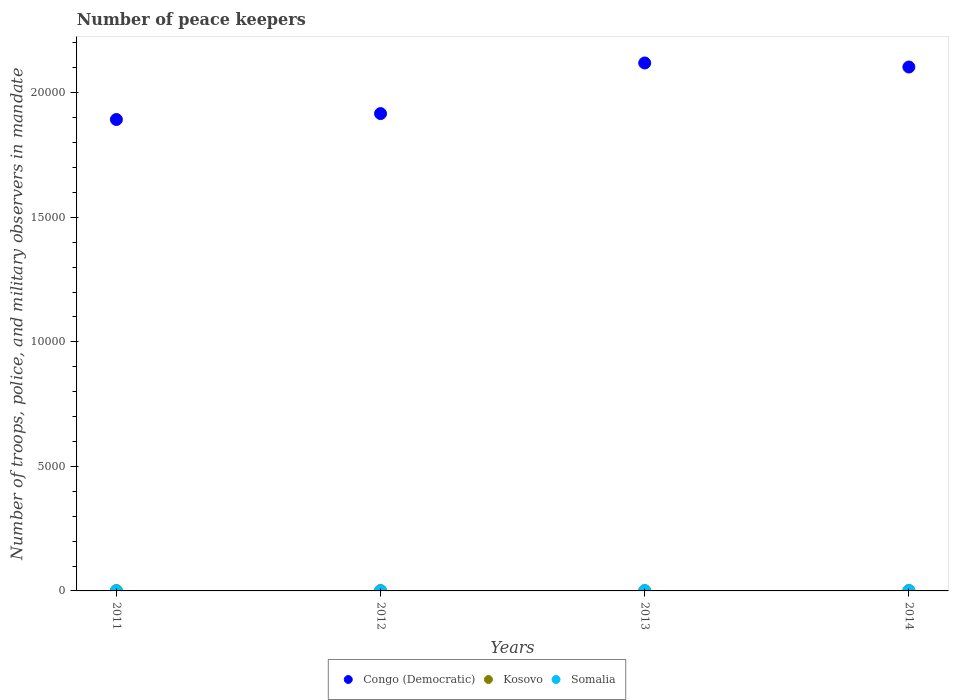How many different coloured dotlines are there?
Make the answer very short. 3. Across all years, what is the maximum number of peace keepers in in Congo (Democratic)?
Keep it short and to the point. 2.12e+04. Across all years, what is the minimum number of peace keepers in in Congo (Democratic)?
Your response must be concise. 1.89e+04. In which year was the number of peace keepers in in Kosovo minimum?
Your answer should be compact. 2013. What is the difference between the number of peace keepers in in Congo (Democratic) in 2011 and that in 2013?
Provide a succinct answer. -2270. What is the difference between the number of peace keepers in in Congo (Democratic) in 2011 and the number of peace keepers in in Kosovo in 2012?
Ensure brevity in your answer.  1.89e+04. What is the average number of peace keepers in in Congo (Democratic) per year?
Provide a short and direct response. 2.01e+04. In the year 2014, what is the difference between the number of peace keepers in in Congo (Democratic) and number of peace keepers in in Kosovo?
Provide a succinct answer. 2.10e+04. What is the ratio of the number of peace keepers in in Congo (Democratic) in 2013 to that in 2014?
Offer a very short reply. 1.01. Is the number of peace keepers in in Somalia in 2013 less than that in 2014?
Provide a succinct answer. Yes. Is the difference between the number of peace keepers in in Congo (Democratic) in 2011 and 2013 greater than the difference between the number of peace keepers in in Kosovo in 2011 and 2013?
Your response must be concise. No. Is the sum of the number of peace keepers in in Somalia in 2012 and 2014 greater than the maximum number of peace keepers in in Congo (Democratic) across all years?
Offer a terse response. No. Is the number of peace keepers in in Somalia strictly less than the number of peace keepers in in Kosovo over the years?
Provide a succinct answer. Yes. How many dotlines are there?
Provide a short and direct response. 3. How many years are there in the graph?
Make the answer very short. 4. What is the difference between two consecutive major ticks on the Y-axis?
Give a very brief answer. 5000. Are the values on the major ticks of Y-axis written in scientific E-notation?
Your response must be concise. No. How are the legend labels stacked?
Provide a short and direct response. Horizontal. What is the title of the graph?
Your response must be concise. Number of peace keepers. Does "Liechtenstein" appear as one of the legend labels in the graph?
Provide a short and direct response. No. What is the label or title of the X-axis?
Make the answer very short. Years. What is the label or title of the Y-axis?
Provide a short and direct response. Number of troops, police, and military observers in mandate. What is the Number of troops, police, and military observers in mandate in Congo (Democratic) in 2011?
Your response must be concise. 1.89e+04. What is the Number of troops, police, and military observers in mandate in Kosovo in 2011?
Offer a very short reply. 16. What is the Number of troops, police, and military observers in mandate of Congo (Democratic) in 2012?
Provide a short and direct response. 1.92e+04. What is the Number of troops, police, and military observers in mandate of Congo (Democratic) in 2013?
Provide a short and direct response. 2.12e+04. What is the Number of troops, police, and military observers in mandate in Kosovo in 2013?
Your response must be concise. 14. What is the Number of troops, police, and military observers in mandate of Congo (Democratic) in 2014?
Your answer should be compact. 2.10e+04. What is the Number of troops, police, and military observers in mandate in Kosovo in 2014?
Offer a terse response. 16. What is the Number of troops, police, and military observers in mandate in Somalia in 2014?
Offer a terse response. 12. Across all years, what is the maximum Number of troops, police, and military observers in mandate in Congo (Democratic)?
Your answer should be compact. 2.12e+04. Across all years, what is the maximum Number of troops, police, and military observers in mandate in Somalia?
Keep it short and to the point. 12. Across all years, what is the minimum Number of troops, police, and military observers in mandate of Congo (Democratic)?
Your answer should be compact. 1.89e+04. Across all years, what is the minimum Number of troops, police, and military observers in mandate of Kosovo?
Make the answer very short. 14. Across all years, what is the minimum Number of troops, police, and military observers in mandate of Somalia?
Your answer should be compact. 3. What is the total Number of troops, police, and military observers in mandate in Congo (Democratic) in the graph?
Keep it short and to the point. 8.03e+04. What is the total Number of troops, police, and military observers in mandate of Somalia in the graph?
Give a very brief answer. 30. What is the difference between the Number of troops, police, and military observers in mandate in Congo (Democratic) in 2011 and that in 2012?
Make the answer very short. -238. What is the difference between the Number of troops, police, and military observers in mandate in Kosovo in 2011 and that in 2012?
Give a very brief answer. 0. What is the difference between the Number of troops, police, and military observers in mandate in Somalia in 2011 and that in 2012?
Provide a short and direct response. 3. What is the difference between the Number of troops, police, and military observers in mandate in Congo (Democratic) in 2011 and that in 2013?
Provide a succinct answer. -2270. What is the difference between the Number of troops, police, and military observers in mandate in Congo (Democratic) in 2011 and that in 2014?
Your answer should be very brief. -2108. What is the difference between the Number of troops, police, and military observers in mandate of Congo (Democratic) in 2012 and that in 2013?
Provide a succinct answer. -2032. What is the difference between the Number of troops, police, and military observers in mandate of Kosovo in 2012 and that in 2013?
Your answer should be very brief. 2. What is the difference between the Number of troops, police, and military observers in mandate in Somalia in 2012 and that in 2013?
Offer a very short reply. -6. What is the difference between the Number of troops, police, and military observers in mandate in Congo (Democratic) in 2012 and that in 2014?
Offer a terse response. -1870. What is the difference between the Number of troops, police, and military observers in mandate of Congo (Democratic) in 2013 and that in 2014?
Provide a succinct answer. 162. What is the difference between the Number of troops, police, and military observers in mandate in Kosovo in 2013 and that in 2014?
Provide a short and direct response. -2. What is the difference between the Number of troops, police, and military observers in mandate of Somalia in 2013 and that in 2014?
Your answer should be compact. -3. What is the difference between the Number of troops, police, and military observers in mandate of Congo (Democratic) in 2011 and the Number of troops, police, and military observers in mandate of Kosovo in 2012?
Offer a very short reply. 1.89e+04. What is the difference between the Number of troops, police, and military observers in mandate of Congo (Democratic) in 2011 and the Number of troops, police, and military observers in mandate of Somalia in 2012?
Keep it short and to the point. 1.89e+04. What is the difference between the Number of troops, police, and military observers in mandate of Kosovo in 2011 and the Number of troops, police, and military observers in mandate of Somalia in 2012?
Keep it short and to the point. 13. What is the difference between the Number of troops, police, and military observers in mandate of Congo (Democratic) in 2011 and the Number of troops, police, and military observers in mandate of Kosovo in 2013?
Offer a very short reply. 1.89e+04. What is the difference between the Number of troops, police, and military observers in mandate of Congo (Democratic) in 2011 and the Number of troops, police, and military observers in mandate of Somalia in 2013?
Ensure brevity in your answer.  1.89e+04. What is the difference between the Number of troops, police, and military observers in mandate of Congo (Democratic) in 2011 and the Number of troops, police, and military observers in mandate of Kosovo in 2014?
Offer a very short reply. 1.89e+04. What is the difference between the Number of troops, police, and military observers in mandate in Congo (Democratic) in 2011 and the Number of troops, police, and military observers in mandate in Somalia in 2014?
Your answer should be compact. 1.89e+04. What is the difference between the Number of troops, police, and military observers in mandate of Kosovo in 2011 and the Number of troops, police, and military observers in mandate of Somalia in 2014?
Your answer should be very brief. 4. What is the difference between the Number of troops, police, and military observers in mandate in Congo (Democratic) in 2012 and the Number of troops, police, and military observers in mandate in Kosovo in 2013?
Offer a very short reply. 1.92e+04. What is the difference between the Number of troops, police, and military observers in mandate of Congo (Democratic) in 2012 and the Number of troops, police, and military observers in mandate of Somalia in 2013?
Your response must be concise. 1.92e+04. What is the difference between the Number of troops, police, and military observers in mandate of Kosovo in 2012 and the Number of troops, police, and military observers in mandate of Somalia in 2013?
Your answer should be very brief. 7. What is the difference between the Number of troops, police, and military observers in mandate of Congo (Democratic) in 2012 and the Number of troops, police, and military observers in mandate of Kosovo in 2014?
Your response must be concise. 1.92e+04. What is the difference between the Number of troops, police, and military observers in mandate in Congo (Democratic) in 2012 and the Number of troops, police, and military observers in mandate in Somalia in 2014?
Provide a succinct answer. 1.92e+04. What is the difference between the Number of troops, police, and military observers in mandate in Kosovo in 2012 and the Number of troops, police, and military observers in mandate in Somalia in 2014?
Offer a terse response. 4. What is the difference between the Number of troops, police, and military observers in mandate in Congo (Democratic) in 2013 and the Number of troops, police, and military observers in mandate in Kosovo in 2014?
Ensure brevity in your answer.  2.12e+04. What is the difference between the Number of troops, police, and military observers in mandate of Congo (Democratic) in 2013 and the Number of troops, police, and military observers in mandate of Somalia in 2014?
Ensure brevity in your answer.  2.12e+04. What is the difference between the Number of troops, police, and military observers in mandate of Kosovo in 2013 and the Number of troops, police, and military observers in mandate of Somalia in 2014?
Make the answer very short. 2. What is the average Number of troops, police, and military observers in mandate of Congo (Democratic) per year?
Your answer should be compact. 2.01e+04. In the year 2011, what is the difference between the Number of troops, police, and military observers in mandate in Congo (Democratic) and Number of troops, police, and military observers in mandate in Kosovo?
Your answer should be compact. 1.89e+04. In the year 2011, what is the difference between the Number of troops, police, and military observers in mandate in Congo (Democratic) and Number of troops, police, and military observers in mandate in Somalia?
Your response must be concise. 1.89e+04. In the year 2012, what is the difference between the Number of troops, police, and military observers in mandate in Congo (Democratic) and Number of troops, police, and military observers in mandate in Kosovo?
Offer a very short reply. 1.92e+04. In the year 2012, what is the difference between the Number of troops, police, and military observers in mandate in Congo (Democratic) and Number of troops, police, and military observers in mandate in Somalia?
Give a very brief answer. 1.92e+04. In the year 2012, what is the difference between the Number of troops, police, and military observers in mandate in Kosovo and Number of troops, police, and military observers in mandate in Somalia?
Offer a very short reply. 13. In the year 2013, what is the difference between the Number of troops, police, and military observers in mandate of Congo (Democratic) and Number of troops, police, and military observers in mandate of Kosovo?
Your answer should be very brief. 2.12e+04. In the year 2013, what is the difference between the Number of troops, police, and military observers in mandate in Congo (Democratic) and Number of troops, police, and military observers in mandate in Somalia?
Your answer should be very brief. 2.12e+04. In the year 2013, what is the difference between the Number of troops, police, and military observers in mandate in Kosovo and Number of troops, police, and military observers in mandate in Somalia?
Your answer should be compact. 5. In the year 2014, what is the difference between the Number of troops, police, and military observers in mandate of Congo (Democratic) and Number of troops, police, and military observers in mandate of Kosovo?
Offer a terse response. 2.10e+04. In the year 2014, what is the difference between the Number of troops, police, and military observers in mandate in Congo (Democratic) and Number of troops, police, and military observers in mandate in Somalia?
Your answer should be compact. 2.10e+04. What is the ratio of the Number of troops, police, and military observers in mandate of Congo (Democratic) in 2011 to that in 2012?
Provide a short and direct response. 0.99. What is the ratio of the Number of troops, police, and military observers in mandate of Somalia in 2011 to that in 2012?
Provide a short and direct response. 2. What is the ratio of the Number of troops, police, and military observers in mandate of Congo (Democratic) in 2011 to that in 2013?
Provide a succinct answer. 0.89. What is the ratio of the Number of troops, police, and military observers in mandate of Somalia in 2011 to that in 2013?
Give a very brief answer. 0.67. What is the ratio of the Number of troops, police, and military observers in mandate in Congo (Democratic) in 2011 to that in 2014?
Your response must be concise. 0.9. What is the ratio of the Number of troops, police, and military observers in mandate in Somalia in 2011 to that in 2014?
Your answer should be very brief. 0.5. What is the ratio of the Number of troops, police, and military observers in mandate of Congo (Democratic) in 2012 to that in 2013?
Your answer should be compact. 0.9. What is the ratio of the Number of troops, police, and military observers in mandate of Somalia in 2012 to that in 2013?
Give a very brief answer. 0.33. What is the ratio of the Number of troops, police, and military observers in mandate of Congo (Democratic) in 2012 to that in 2014?
Your answer should be very brief. 0.91. What is the ratio of the Number of troops, police, and military observers in mandate of Kosovo in 2012 to that in 2014?
Make the answer very short. 1. What is the ratio of the Number of troops, police, and military observers in mandate of Somalia in 2012 to that in 2014?
Your answer should be compact. 0.25. What is the ratio of the Number of troops, police, and military observers in mandate in Congo (Democratic) in 2013 to that in 2014?
Offer a very short reply. 1.01. What is the ratio of the Number of troops, police, and military observers in mandate of Kosovo in 2013 to that in 2014?
Keep it short and to the point. 0.88. What is the ratio of the Number of troops, police, and military observers in mandate of Somalia in 2013 to that in 2014?
Ensure brevity in your answer.  0.75. What is the difference between the highest and the second highest Number of troops, police, and military observers in mandate of Congo (Democratic)?
Give a very brief answer. 162. What is the difference between the highest and the lowest Number of troops, police, and military observers in mandate of Congo (Democratic)?
Make the answer very short. 2270. 